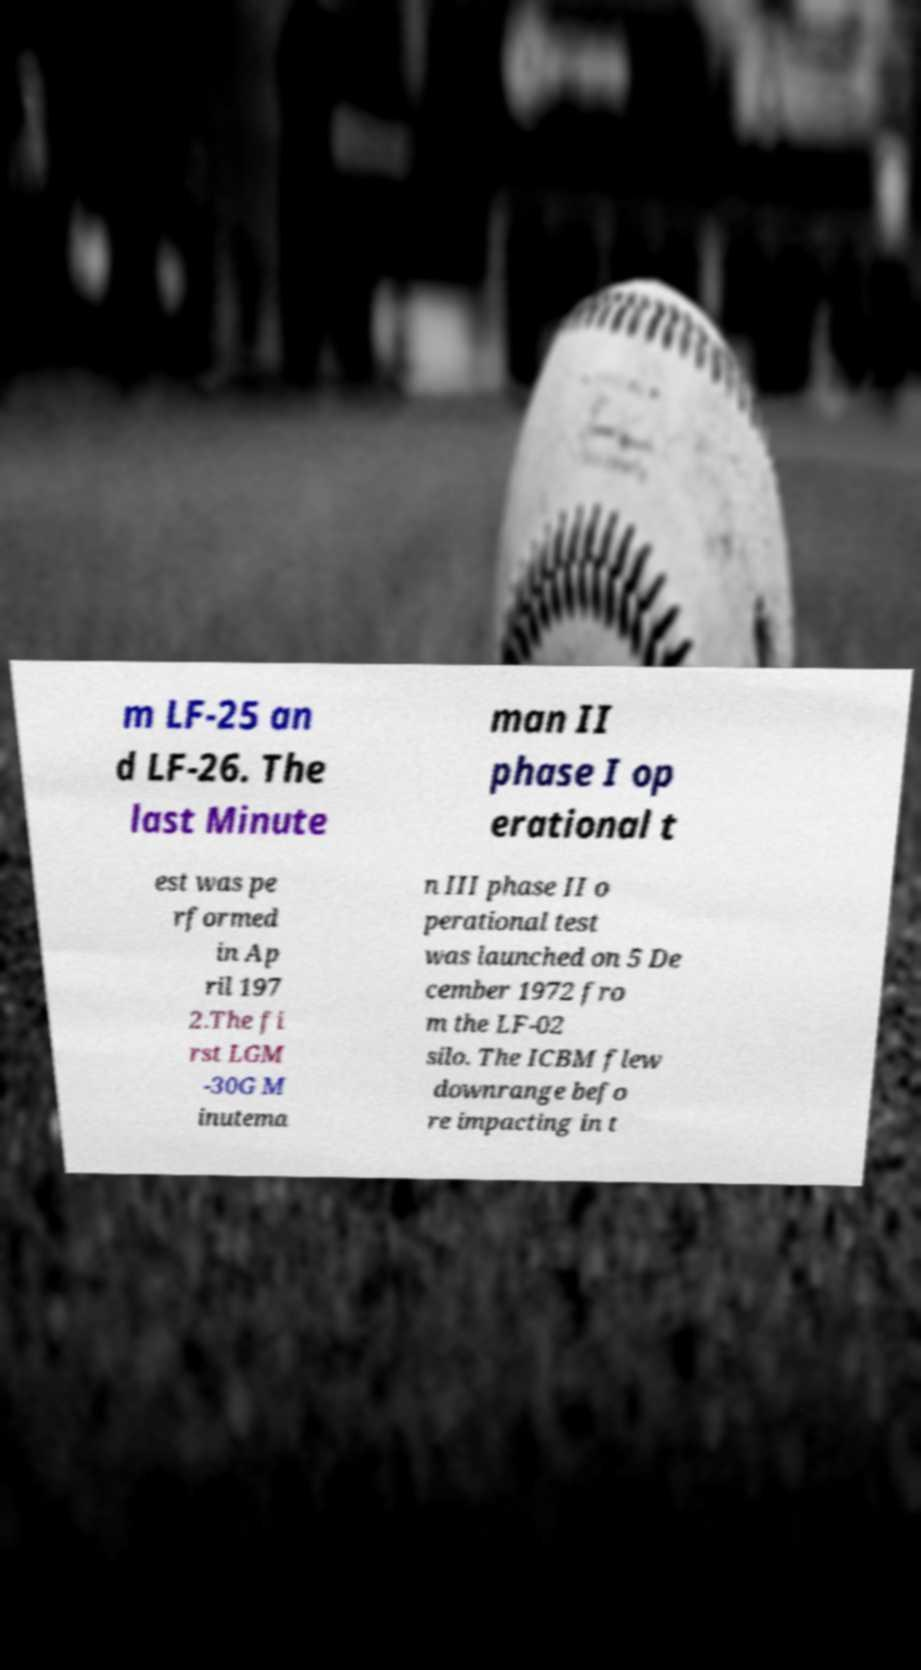Please identify and transcribe the text found in this image. m LF-25 an d LF-26. The last Minute man II phase I op erational t est was pe rformed in Ap ril 197 2.The fi rst LGM -30G M inutema n III phase II o perational test was launched on 5 De cember 1972 fro m the LF-02 silo. The ICBM flew downrange befo re impacting in t 